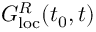Convert formula to latex. <formula><loc_0><loc_0><loc_500><loc_500>G _ { l o c } ^ { R } ( t _ { 0 } , t )</formula> 